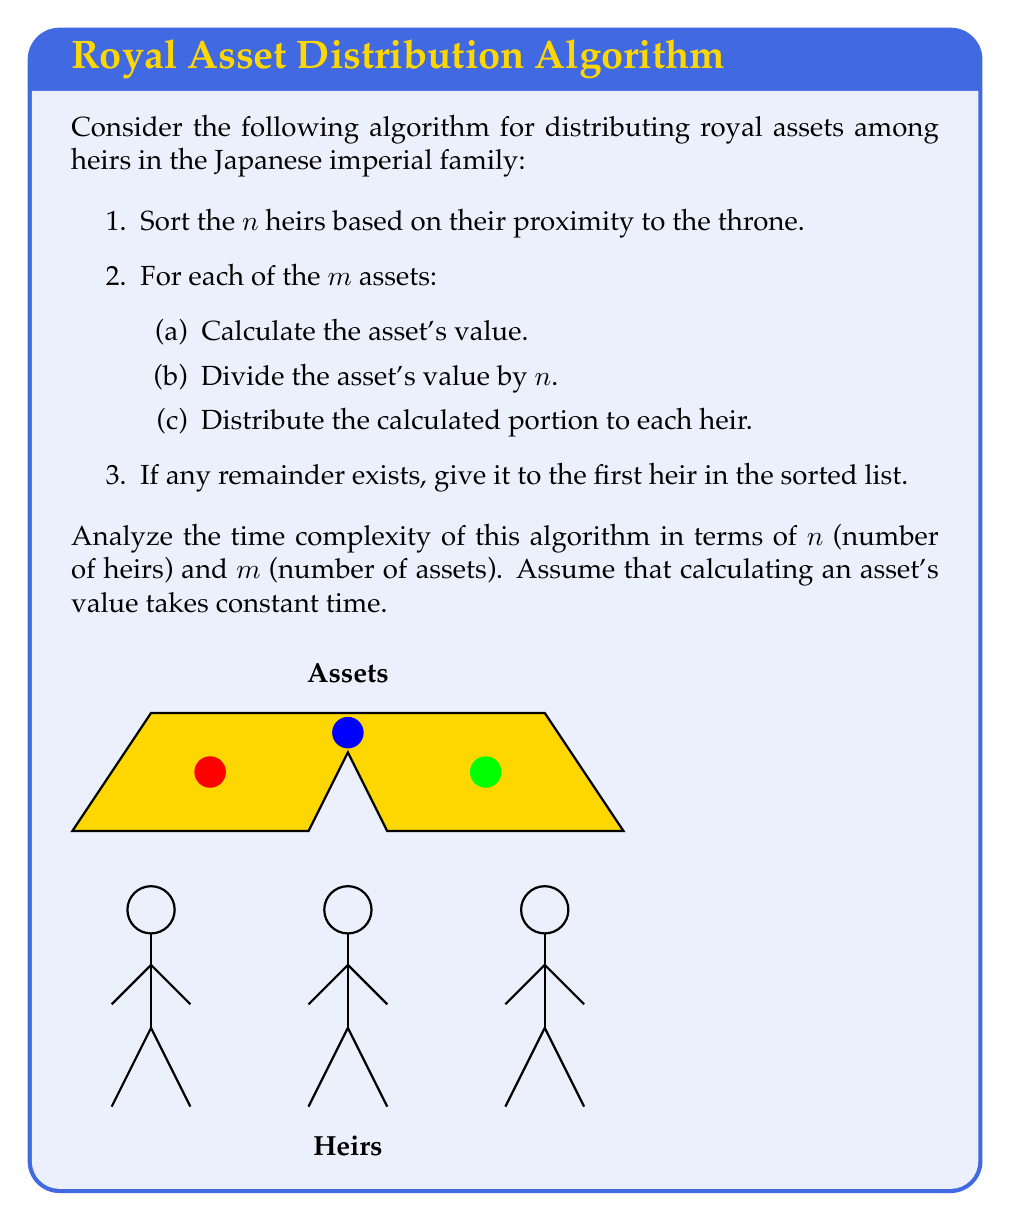Help me with this question. Let's analyze the algorithm step by step:

1. Sorting the heirs:
   The best comparison-based sorting algorithms have a time complexity of $O(n \log n)$, where n is the number of heirs.

2. For each asset (m times):
   a. Calculating the asset's value: $O(1)$ (given in the problem)
   b. Dividing the asset's value by n: $O(1)$
   c. Distributing the calculated portion to each heir: $O(n)$

   The total complexity for step 2 is $O(m \cdot (1 + 1 + n)) = O(mn)$

3. Giving the remainder to the first heir: $O(1)$

Now, let's combine these steps:

$$ T(n,m) = O(n \log n) + O(mn) + O(1) $$

Simplifying:

$$ T(n,m) = O(n \log n + mn) $$

To determine which term dominates, we need to compare $n \log n$ and $mn$:

- If $m < \log n$, then $n \log n$ dominates
- If $m > \log n$, then $mn$ dominates

Therefore, we can express the overall time complexity as:

$$ T(n,m) = O(\max(n \log n, mn)) $$

This means the algorithm's time complexity is the larger of $n \log n$ and $mn$.
Answer: $O(\max(n \log n, mn))$ 